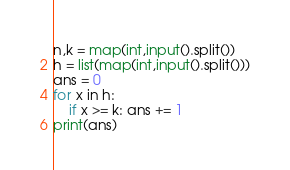<code> <loc_0><loc_0><loc_500><loc_500><_Python_>n,k = map(int,input().split())
h = list(map(int,input().split()))
ans = 0
for x in h:
    if x >= k: ans += 1
print(ans)</code> 